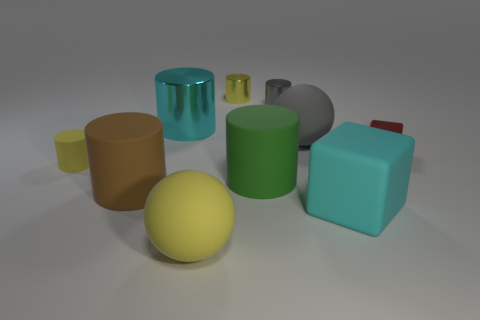There is a cyan thing to the left of the cyan object that is right of the tiny yellow metallic cylinder; what is its size?
Your response must be concise. Large. Does the big shiny thing have the same color as the large sphere that is in front of the large gray matte thing?
Your answer should be compact. No. What number of other things are there of the same material as the big cyan cylinder
Your answer should be compact. 3. The small yellow object that is the same material as the small gray object is what shape?
Your answer should be compact. Cylinder. Is there anything else that has the same color as the small block?
Your response must be concise. No. What size is the metallic object that is the same color as the rubber cube?
Offer a terse response. Large. Are there more big matte spheres that are in front of the cyan cube than brown matte cylinders?
Provide a succinct answer. No. Do the green thing and the matte thing behind the red thing have the same shape?
Provide a short and direct response. No. How many brown objects are the same size as the cyan cube?
Keep it short and to the point. 1. How many brown cylinders are on the right side of the gray object behind the large ball behind the tiny metal block?
Your answer should be compact. 0. 